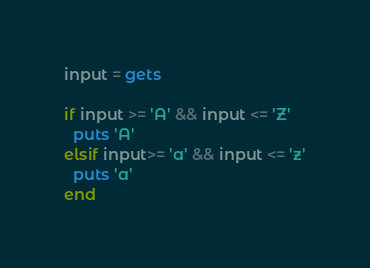Convert code to text. <code><loc_0><loc_0><loc_500><loc_500><_Ruby_>input = gets

if input >= 'A' && input <= 'Z'
  puts 'A'
elsif input>= 'a' && input <= 'z'
  puts 'a'
end</code> 